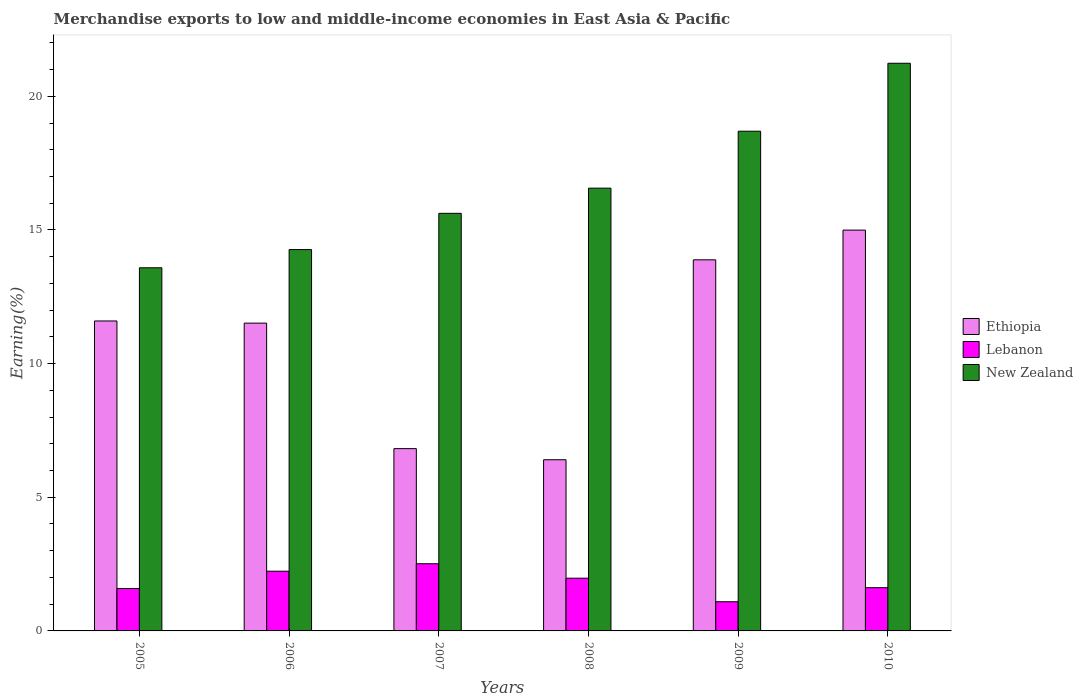How many different coloured bars are there?
Make the answer very short. 3. How many groups of bars are there?
Provide a short and direct response. 6. Are the number of bars on each tick of the X-axis equal?
Provide a short and direct response. Yes. How many bars are there on the 4th tick from the left?
Ensure brevity in your answer.  3. How many bars are there on the 2nd tick from the right?
Offer a very short reply. 3. What is the label of the 4th group of bars from the left?
Provide a short and direct response. 2008. In how many cases, is the number of bars for a given year not equal to the number of legend labels?
Ensure brevity in your answer.  0. What is the percentage of amount earned from merchandise exports in Lebanon in 2007?
Provide a succinct answer. 2.51. Across all years, what is the maximum percentage of amount earned from merchandise exports in New Zealand?
Offer a terse response. 21.24. Across all years, what is the minimum percentage of amount earned from merchandise exports in Lebanon?
Make the answer very short. 1.09. What is the total percentage of amount earned from merchandise exports in New Zealand in the graph?
Your response must be concise. 99.96. What is the difference between the percentage of amount earned from merchandise exports in Ethiopia in 2009 and that in 2010?
Offer a very short reply. -1.11. What is the difference between the percentage of amount earned from merchandise exports in Ethiopia in 2010 and the percentage of amount earned from merchandise exports in New Zealand in 2006?
Your response must be concise. 0.73. What is the average percentage of amount earned from merchandise exports in Ethiopia per year?
Keep it short and to the point. 10.87. In the year 2009, what is the difference between the percentage of amount earned from merchandise exports in Ethiopia and percentage of amount earned from merchandise exports in Lebanon?
Offer a very short reply. 12.79. What is the ratio of the percentage of amount earned from merchandise exports in Lebanon in 2007 to that in 2008?
Your answer should be very brief. 1.27. Is the difference between the percentage of amount earned from merchandise exports in Ethiopia in 2007 and 2010 greater than the difference between the percentage of amount earned from merchandise exports in Lebanon in 2007 and 2010?
Your answer should be compact. No. What is the difference between the highest and the second highest percentage of amount earned from merchandise exports in New Zealand?
Offer a terse response. 2.54. What is the difference between the highest and the lowest percentage of amount earned from merchandise exports in New Zealand?
Offer a terse response. 7.65. In how many years, is the percentage of amount earned from merchandise exports in New Zealand greater than the average percentage of amount earned from merchandise exports in New Zealand taken over all years?
Your answer should be compact. 2. Is the sum of the percentage of amount earned from merchandise exports in Ethiopia in 2005 and 2007 greater than the maximum percentage of amount earned from merchandise exports in Lebanon across all years?
Your response must be concise. Yes. What does the 1st bar from the left in 2006 represents?
Your answer should be compact. Ethiopia. What does the 1st bar from the right in 2009 represents?
Ensure brevity in your answer.  New Zealand. What is the difference between two consecutive major ticks on the Y-axis?
Keep it short and to the point. 5. Does the graph contain grids?
Provide a short and direct response. No. How are the legend labels stacked?
Provide a succinct answer. Vertical. What is the title of the graph?
Your answer should be compact. Merchandise exports to low and middle-income economies in East Asia & Pacific. Does "Europe(developing only)" appear as one of the legend labels in the graph?
Your answer should be very brief. No. What is the label or title of the Y-axis?
Provide a short and direct response. Earning(%). What is the Earning(%) of Ethiopia in 2005?
Keep it short and to the point. 11.6. What is the Earning(%) in Lebanon in 2005?
Offer a very short reply. 1.59. What is the Earning(%) in New Zealand in 2005?
Make the answer very short. 13.58. What is the Earning(%) of Ethiopia in 2006?
Keep it short and to the point. 11.51. What is the Earning(%) of Lebanon in 2006?
Ensure brevity in your answer.  2.23. What is the Earning(%) in New Zealand in 2006?
Your answer should be compact. 14.27. What is the Earning(%) of Ethiopia in 2007?
Offer a terse response. 6.82. What is the Earning(%) of Lebanon in 2007?
Your response must be concise. 2.51. What is the Earning(%) of New Zealand in 2007?
Your response must be concise. 15.62. What is the Earning(%) of Ethiopia in 2008?
Provide a short and direct response. 6.4. What is the Earning(%) of Lebanon in 2008?
Your answer should be compact. 1.97. What is the Earning(%) of New Zealand in 2008?
Offer a very short reply. 16.56. What is the Earning(%) of Ethiopia in 2009?
Make the answer very short. 13.88. What is the Earning(%) in Lebanon in 2009?
Ensure brevity in your answer.  1.09. What is the Earning(%) in New Zealand in 2009?
Ensure brevity in your answer.  18.69. What is the Earning(%) in Ethiopia in 2010?
Provide a succinct answer. 14.99. What is the Earning(%) of Lebanon in 2010?
Your answer should be very brief. 1.62. What is the Earning(%) of New Zealand in 2010?
Provide a succinct answer. 21.24. Across all years, what is the maximum Earning(%) of Ethiopia?
Your response must be concise. 14.99. Across all years, what is the maximum Earning(%) of Lebanon?
Make the answer very short. 2.51. Across all years, what is the maximum Earning(%) in New Zealand?
Your answer should be very brief. 21.24. Across all years, what is the minimum Earning(%) of Ethiopia?
Offer a very short reply. 6.4. Across all years, what is the minimum Earning(%) of Lebanon?
Ensure brevity in your answer.  1.09. Across all years, what is the minimum Earning(%) in New Zealand?
Your answer should be very brief. 13.58. What is the total Earning(%) of Ethiopia in the graph?
Your answer should be compact. 65.21. What is the total Earning(%) in Lebanon in the graph?
Your response must be concise. 11.01. What is the total Earning(%) in New Zealand in the graph?
Your answer should be very brief. 99.96. What is the difference between the Earning(%) of Ethiopia in 2005 and that in 2006?
Give a very brief answer. 0.08. What is the difference between the Earning(%) in Lebanon in 2005 and that in 2006?
Ensure brevity in your answer.  -0.65. What is the difference between the Earning(%) in New Zealand in 2005 and that in 2006?
Make the answer very short. -0.68. What is the difference between the Earning(%) in Ethiopia in 2005 and that in 2007?
Your answer should be very brief. 4.78. What is the difference between the Earning(%) of Lebanon in 2005 and that in 2007?
Provide a succinct answer. -0.93. What is the difference between the Earning(%) in New Zealand in 2005 and that in 2007?
Your answer should be very brief. -2.04. What is the difference between the Earning(%) of Ethiopia in 2005 and that in 2008?
Offer a terse response. 5.19. What is the difference between the Earning(%) of Lebanon in 2005 and that in 2008?
Provide a succinct answer. -0.39. What is the difference between the Earning(%) in New Zealand in 2005 and that in 2008?
Provide a succinct answer. -2.98. What is the difference between the Earning(%) in Ethiopia in 2005 and that in 2009?
Offer a very short reply. -2.29. What is the difference between the Earning(%) of Lebanon in 2005 and that in 2009?
Offer a terse response. 0.49. What is the difference between the Earning(%) of New Zealand in 2005 and that in 2009?
Offer a very short reply. -5.11. What is the difference between the Earning(%) of Ethiopia in 2005 and that in 2010?
Ensure brevity in your answer.  -3.4. What is the difference between the Earning(%) in Lebanon in 2005 and that in 2010?
Offer a very short reply. -0.03. What is the difference between the Earning(%) in New Zealand in 2005 and that in 2010?
Your response must be concise. -7.65. What is the difference between the Earning(%) in Ethiopia in 2006 and that in 2007?
Keep it short and to the point. 4.7. What is the difference between the Earning(%) of Lebanon in 2006 and that in 2007?
Your answer should be compact. -0.28. What is the difference between the Earning(%) in New Zealand in 2006 and that in 2007?
Give a very brief answer. -1.36. What is the difference between the Earning(%) of Ethiopia in 2006 and that in 2008?
Your answer should be compact. 5.11. What is the difference between the Earning(%) of Lebanon in 2006 and that in 2008?
Your answer should be compact. 0.26. What is the difference between the Earning(%) in New Zealand in 2006 and that in 2008?
Give a very brief answer. -2.3. What is the difference between the Earning(%) in Ethiopia in 2006 and that in 2009?
Provide a succinct answer. -2.37. What is the difference between the Earning(%) in Lebanon in 2006 and that in 2009?
Offer a terse response. 1.14. What is the difference between the Earning(%) of New Zealand in 2006 and that in 2009?
Your response must be concise. -4.43. What is the difference between the Earning(%) in Ethiopia in 2006 and that in 2010?
Make the answer very short. -3.48. What is the difference between the Earning(%) in Lebanon in 2006 and that in 2010?
Your answer should be very brief. 0.62. What is the difference between the Earning(%) of New Zealand in 2006 and that in 2010?
Provide a succinct answer. -6.97. What is the difference between the Earning(%) of Ethiopia in 2007 and that in 2008?
Offer a very short reply. 0.42. What is the difference between the Earning(%) in Lebanon in 2007 and that in 2008?
Make the answer very short. 0.54. What is the difference between the Earning(%) of New Zealand in 2007 and that in 2008?
Make the answer very short. -0.94. What is the difference between the Earning(%) of Ethiopia in 2007 and that in 2009?
Provide a succinct answer. -7.06. What is the difference between the Earning(%) of Lebanon in 2007 and that in 2009?
Offer a very short reply. 1.42. What is the difference between the Earning(%) in New Zealand in 2007 and that in 2009?
Offer a very short reply. -3.07. What is the difference between the Earning(%) in Ethiopia in 2007 and that in 2010?
Offer a very short reply. -8.17. What is the difference between the Earning(%) in Lebanon in 2007 and that in 2010?
Offer a terse response. 0.9. What is the difference between the Earning(%) in New Zealand in 2007 and that in 2010?
Provide a short and direct response. -5.61. What is the difference between the Earning(%) in Ethiopia in 2008 and that in 2009?
Your response must be concise. -7.48. What is the difference between the Earning(%) in Lebanon in 2008 and that in 2009?
Offer a very short reply. 0.88. What is the difference between the Earning(%) of New Zealand in 2008 and that in 2009?
Ensure brevity in your answer.  -2.13. What is the difference between the Earning(%) in Ethiopia in 2008 and that in 2010?
Keep it short and to the point. -8.59. What is the difference between the Earning(%) in Lebanon in 2008 and that in 2010?
Your answer should be very brief. 0.35. What is the difference between the Earning(%) in New Zealand in 2008 and that in 2010?
Your response must be concise. -4.67. What is the difference between the Earning(%) in Ethiopia in 2009 and that in 2010?
Your answer should be compact. -1.11. What is the difference between the Earning(%) of Lebanon in 2009 and that in 2010?
Give a very brief answer. -0.53. What is the difference between the Earning(%) of New Zealand in 2009 and that in 2010?
Your answer should be compact. -2.54. What is the difference between the Earning(%) of Ethiopia in 2005 and the Earning(%) of Lebanon in 2006?
Keep it short and to the point. 9.36. What is the difference between the Earning(%) of Ethiopia in 2005 and the Earning(%) of New Zealand in 2006?
Ensure brevity in your answer.  -2.67. What is the difference between the Earning(%) of Lebanon in 2005 and the Earning(%) of New Zealand in 2006?
Offer a terse response. -12.68. What is the difference between the Earning(%) of Ethiopia in 2005 and the Earning(%) of Lebanon in 2007?
Offer a terse response. 9.08. What is the difference between the Earning(%) of Ethiopia in 2005 and the Earning(%) of New Zealand in 2007?
Your answer should be very brief. -4.03. What is the difference between the Earning(%) of Lebanon in 2005 and the Earning(%) of New Zealand in 2007?
Your answer should be compact. -14.04. What is the difference between the Earning(%) in Ethiopia in 2005 and the Earning(%) in Lebanon in 2008?
Provide a short and direct response. 9.62. What is the difference between the Earning(%) in Ethiopia in 2005 and the Earning(%) in New Zealand in 2008?
Make the answer very short. -4.97. What is the difference between the Earning(%) of Lebanon in 2005 and the Earning(%) of New Zealand in 2008?
Offer a terse response. -14.98. What is the difference between the Earning(%) in Ethiopia in 2005 and the Earning(%) in Lebanon in 2009?
Provide a succinct answer. 10.5. What is the difference between the Earning(%) of Ethiopia in 2005 and the Earning(%) of New Zealand in 2009?
Your response must be concise. -7.1. What is the difference between the Earning(%) in Lebanon in 2005 and the Earning(%) in New Zealand in 2009?
Ensure brevity in your answer.  -17.11. What is the difference between the Earning(%) of Ethiopia in 2005 and the Earning(%) of Lebanon in 2010?
Keep it short and to the point. 9.98. What is the difference between the Earning(%) of Ethiopia in 2005 and the Earning(%) of New Zealand in 2010?
Your answer should be compact. -9.64. What is the difference between the Earning(%) in Lebanon in 2005 and the Earning(%) in New Zealand in 2010?
Offer a very short reply. -19.65. What is the difference between the Earning(%) in Ethiopia in 2006 and the Earning(%) in Lebanon in 2007?
Offer a terse response. 9. What is the difference between the Earning(%) in Ethiopia in 2006 and the Earning(%) in New Zealand in 2007?
Give a very brief answer. -4.11. What is the difference between the Earning(%) of Lebanon in 2006 and the Earning(%) of New Zealand in 2007?
Your answer should be very brief. -13.39. What is the difference between the Earning(%) of Ethiopia in 2006 and the Earning(%) of Lebanon in 2008?
Give a very brief answer. 9.54. What is the difference between the Earning(%) of Ethiopia in 2006 and the Earning(%) of New Zealand in 2008?
Make the answer very short. -5.05. What is the difference between the Earning(%) of Lebanon in 2006 and the Earning(%) of New Zealand in 2008?
Provide a succinct answer. -14.33. What is the difference between the Earning(%) of Ethiopia in 2006 and the Earning(%) of Lebanon in 2009?
Your response must be concise. 10.42. What is the difference between the Earning(%) in Ethiopia in 2006 and the Earning(%) in New Zealand in 2009?
Offer a terse response. -7.18. What is the difference between the Earning(%) in Lebanon in 2006 and the Earning(%) in New Zealand in 2009?
Provide a succinct answer. -16.46. What is the difference between the Earning(%) of Ethiopia in 2006 and the Earning(%) of Lebanon in 2010?
Your answer should be compact. 9.9. What is the difference between the Earning(%) of Ethiopia in 2006 and the Earning(%) of New Zealand in 2010?
Your answer should be compact. -9.72. What is the difference between the Earning(%) of Lebanon in 2006 and the Earning(%) of New Zealand in 2010?
Your answer should be very brief. -19. What is the difference between the Earning(%) of Ethiopia in 2007 and the Earning(%) of Lebanon in 2008?
Offer a very short reply. 4.85. What is the difference between the Earning(%) in Ethiopia in 2007 and the Earning(%) in New Zealand in 2008?
Provide a succinct answer. -9.74. What is the difference between the Earning(%) of Lebanon in 2007 and the Earning(%) of New Zealand in 2008?
Make the answer very short. -14.05. What is the difference between the Earning(%) of Ethiopia in 2007 and the Earning(%) of Lebanon in 2009?
Offer a very short reply. 5.73. What is the difference between the Earning(%) in Ethiopia in 2007 and the Earning(%) in New Zealand in 2009?
Provide a short and direct response. -11.87. What is the difference between the Earning(%) of Lebanon in 2007 and the Earning(%) of New Zealand in 2009?
Provide a succinct answer. -16.18. What is the difference between the Earning(%) in Ethiopia in 2007 and the Earning(%) in Lebanon in 2010?
Provide a short and direct response. 5.2. What is the difference between the Earning(%) in Ethiopia in 2007 and the Earning(%) in New Zealand in 2010?
Your answer should be compact. -14.42. What is the difference between the Earning(%) in Lebanon in 2007 and the Earning(%) in New Zealand in 2010?
Offer a terse response. -18.72. What is the difference between the Earning(%) in Ethiopia in 2008 and the Earning(%) in Lebanon in 2009?
Provide a succinct answer. 5.31. What is the difference between the Earning(%) in Ethiopia in 2008 and the Earning(%) in New Zealand in 2009?
Your answer should be compact. -12.29. What is the difference between the Earning(%) of Lebanon in 2008 and the Earning(%) of New Zealand in 2009?
Your answer should be compact. -16.72. What is the difference between the Earning(%) in Ethiopia in 2008 and the Earning(%) in Lebanon in 2010?
Keep it short and to the point. 4.79. What is the difference between the Earning(%) in Ethiopia in 2008 and the Earning(%) in New Zealand in 2010?
Your answer should be very brief. -14.83. What is the difference between the Earning(%) in Lebanon in 2008 and the Earning(%) in New Zealand in 2010?
Make the answer very short. -19.26. What is the difference between the Earning(%) of Ethiopia in 2009 and the Earning(%) of Lebanon in 2010?
Your answer should be very brief. 12.26. What is the difference between the Earning(%) of Ethiopia in 2009 and the Earning(%) of New Zealand in 2010?
Provide a succinct answer. -7.35. What is the difference between the Earning(%) in Lebanon in 2009 and the Earning(%) in New Zealand in 2010?
Offer a very short reply. -20.14. What is the average Earning(%) in Ethiopia per year?
Provide a succinct answer. 10.87. What is the average Earning(%) in Lebanon per year?
Your answer should be very brief. 1.84. What is the average Earning(%) in New Zealand per year?
Keep it short and to the point. 16.66. In the year 2005, what is the difference between the Earning(%) of Ethiopia and Earning(%) of Lebanon?
Give a very brief answer. 10.01. In the year 2005, what is the difference between the Earning(%) of Ethiopia and Earning(%) of New Zealand?
Your answer should be very brief. -1.99. In the year 2005, what is the difference between the Earning(%) of Lebanon and Earning(%) of New Zealand?
Give a very brief answer. -12. In the year 2006, what is the difference between the Earning(%) of Ethiopia and Earning(%) of Lebanon?
Your answer should be compact. 9.28. In the year 2006, what is the difference between the Earning(%) in Ethiopia and Earning(%) in New Zealand?
Your answer should be very brief. -2.75. In the year 2006, what is the difference between the Earning(%) of Lebanon and Earning(%) of New Zealand?
Keep it short and to the point. -12.03. In the year 2007, what is the difference between the Earning(%) of Ethiopia and Earning(%) of Lebanon?
Provide a short and direct response. 4.31. In the year 2007, what is the difference between the Earning(%) of Ethiopia and Earning(%) of New Zealand?
Offer a very short reply. -8.8. In the year 2007, what is the difference between the Earning(%) of Lebanon and Earning(%) of New Zealand?
Keep it short and to the point. -13.11. In the year 2008, what is the difference between the Earning(%) of Ethiopia and Earning(%) of Lebanon?
Give a very brief answer. 4.43. In the year 2008, what is the difference between the Earning(%) of Ethiopia and Earning(%) of New Zealand?
Provide a short and direct response. -10.16. In the year 2008, what is the difference between the Earning(%) in Lebanon and Earning(%) in New Zealand?
Offer a terse response. -14.59. In the year 2009, what is the difference between the Earning(%) in Ethiopia and Earning(%) in Lebanon?
Your answer should be compact. 12.79. In the year 2009, what is the difference between the Earning(%) in Ethiopia and Earning(%) in New Zealand?
Your answer should be compact. -4.81. In the year 2009, what is the difference between the Earning(%) in Lebanon and Earning(%) in New Zealand?
Your answer should be compact. -17.6. In the year 2010, what is the difference between the Earning(%) of Ethiopia and Earning(%) of Lebanon?
Make the answer very short. 13.38. In the year 2010, what is the difference between the Earning(%) in Ethiopia and Earning(%) in New Zealand?
Your response must be concise. -6.24. In the year 2010, what is the difference between the Earning(%) in Lebanon and Earning(%) in New Zealand?
Provide a succinct answer. -19.62. What is the ratio of the Earning(%) of Lebanon in 2005 to that in 2006?
Offer a very short reply. 0.71. What is the ratio of the Earning(%) of New Zealand in 2005 to that in 2006?
Your answer should be compact. 0.95. What is the ratio of the Earning(%) of Ethiopia in 2005 to that in 2007?
Keep it short and to the point. 1.7. What is the ratio of the Earning(%) of Lebanon in 2005 to that in 2007?
Provide a short and direct response. 0.63. What is the ratio of the Earning(%) of New Zealand in 2005 to that in 2007?
Provide a short and direct response. 0.87. What is the ratio of the Earning(%) of Ethiopia in 2005 to that in 2008?
Your answer should be very brief. 1.81. What is the ratio of the Earning(%) of Lebanon in 2005 to that in 2008?
Offer a very short reply. 0.8. What is the ratio of the Earning(%) of New Zealand in 2005 to that in 2008?
Your answer should be very brief. 0.82. What is the ratio of the Earning(%) in Ethiopia in 2005 to that in 2009?
Offer a terse response. 0.84. What is the ratio of the Earning(%) in Lebanon in 2005 to that in 2009?
Your answer should be compact. 1.45. What is the ratio of the Earning(%) in New Zealand in 2005 to that in 2009?
Offer a terse response. 0.73. What is the ratio of the Earning(%) of Ethiopia in 2005 to that in 2010?
Provide a succinct answer. 0.77. What is the ratio of the Earning(%) in Lebanon in 2005 to that in 2010?
Give a very brief answer. 0.98. What is the ratio of the Earning(%) in New Zealand in 2005 to that in 2010?
Ensure brevity in your answer.  0.64. What is the ratio of the Earning(%) in Ethiopia in 2006 to that in 2007?
Offer a very short reply. 1.69. What is the ratio of the Earning(%) in Lebanon in 2006 to that in 2007?
Make the answer very short. 0.89. What is the ratio of the Earning(%) of New Zealand in 2006 to that in 2007?
Your response must be concise. 0.91. What is the ratio of the Earning(%) in Ethiopia in 2006 to that in 2008?
Provide a short and direct response. 1.8. What is the ratio of the Earning(%) of Lebanon in 2006 to that in 2008?
Offer a terse response. 1.13. What is the ratio of the Earning(%) in New Zealand in 2006 to that in 2008?
Your answer should be compact. 0.86. What is the ratio of the Earning(%) of Ethiopia in 2006 to that in 2009?
Ensure brevity in your answer.  0.83. What is the ratio of the Earning(%) in Lebanon in 2006 to that in 2009?
Your response must be concise. 2.05. What is the ratio of the Earning(%) of New Zealand in 2006 to that in 2009?
Give a very brief answer. 0.76. What is the ratio of the Earning(%) in Ethiopia in 2006 to that in 2010?
Keep it short and to the point. 0.77. What is the ratio of the Earning(%) of Lebanon in 2006 to that in 2010?
Provide a succinct answer. 1.38. What is the ratio of the Earning(%) in New Zealand in 2006 to that in 2010?
Provide a succinct answer. 0.67. What is the ratio of the Earning(%) of Ethiopia in 2007 to that in 2008?
Your answer should be compact. 1.06. What is the ratio of the Earning(%) in Lebanon in 2007 to that in 2008?
Make the answer very short. 1.27. What is the ratio of the Earning(%) in New Zealand in 2007 to that in 2008?
Your answer should be compact. 0.94. What is the ratio of the Earning(%) of Ethiopia in 2007 to that in 2009?
Keep it short and to the point. 0.49. What is the ratio of the Earning(%) of Lebanon in 2007 to that in 2009?
Your answer should be compact. 2.3. What is the ratio of the Earning(%) in New Zealand in 2007 to that in 2009?
Offer a very short reply. 0.84. What is the ratio of the Earning(%) of Ethiopia in 2007 to that in 2010?
Your answer should be compact. 0.45. What is the ratio of the Earning(%) in Lebanon in 2007 to that in 2010?
Provide a succinct answer. 1.55. What is the ratio of the Earning(%) in New Zealand in 2007 to that in 2010?
Ensure brevity in your answer.  0.74. What is the ratio of the Earning(%) in Ethiopia in 2008 to that in 2009?
Offer a terse response. 0.46. What is the ratio of the Earning(%) of Lebanon in 2008 to that in 2009?
Give a very brief answer. 1.81. What is the ratio of the Earning(%) of New Zealand in 2008 to that in 2009?
Provide a short and direct response. 0.89. What is the ratio of the Earning(%) of Ethiopia in 2008 to that in 2010?
Your answer should be compact. 0.43. What is the ratio of the Earning(%) of Lebanon in 2008 to that in 2010?
Your response must be concise. 1.22. What is the ratio of the Earning(%) in New Zealand in 2008 to that in 2010?
Your answer should be very brief. 0.78. What is the ratio of the Earning(%) in Ethiopia in 2009 to that in 2010?
Ensure brevity in your answer.  0.93. What is the ratio of the Earning(%) of Lebanon in 2009 to that in 2010?
Provide a succinct answer. 0.67. What is the ratio of the Earning(%) of New Zealand in 2009 to that in 2010?
Keep it short and to the point. 0.88. What is the difference between the highest and the second highest Earning(%) of Ethiopia?
Your response must be concise. 1.11. What is the difference between the highest and the second highest Earning(%) in Lebanon?
Provide a succinct answer. 0.28. What is the difference between the highest and the second highest Earning(%) of New Zealand?
Ensure brevity in your answer.  2.54. What is the difference between the highest and the lowest Earning(%) of Ethiopia?
Offer a terse response. 8.59. What is the difference between the highest and the lowest Earning(%) in Lebanon?
Provide a succinct answer. 1.42. What is the difference between the highest and the lowest Earning(%) of New Zealand?
Your answer should be compact. 7.65. 